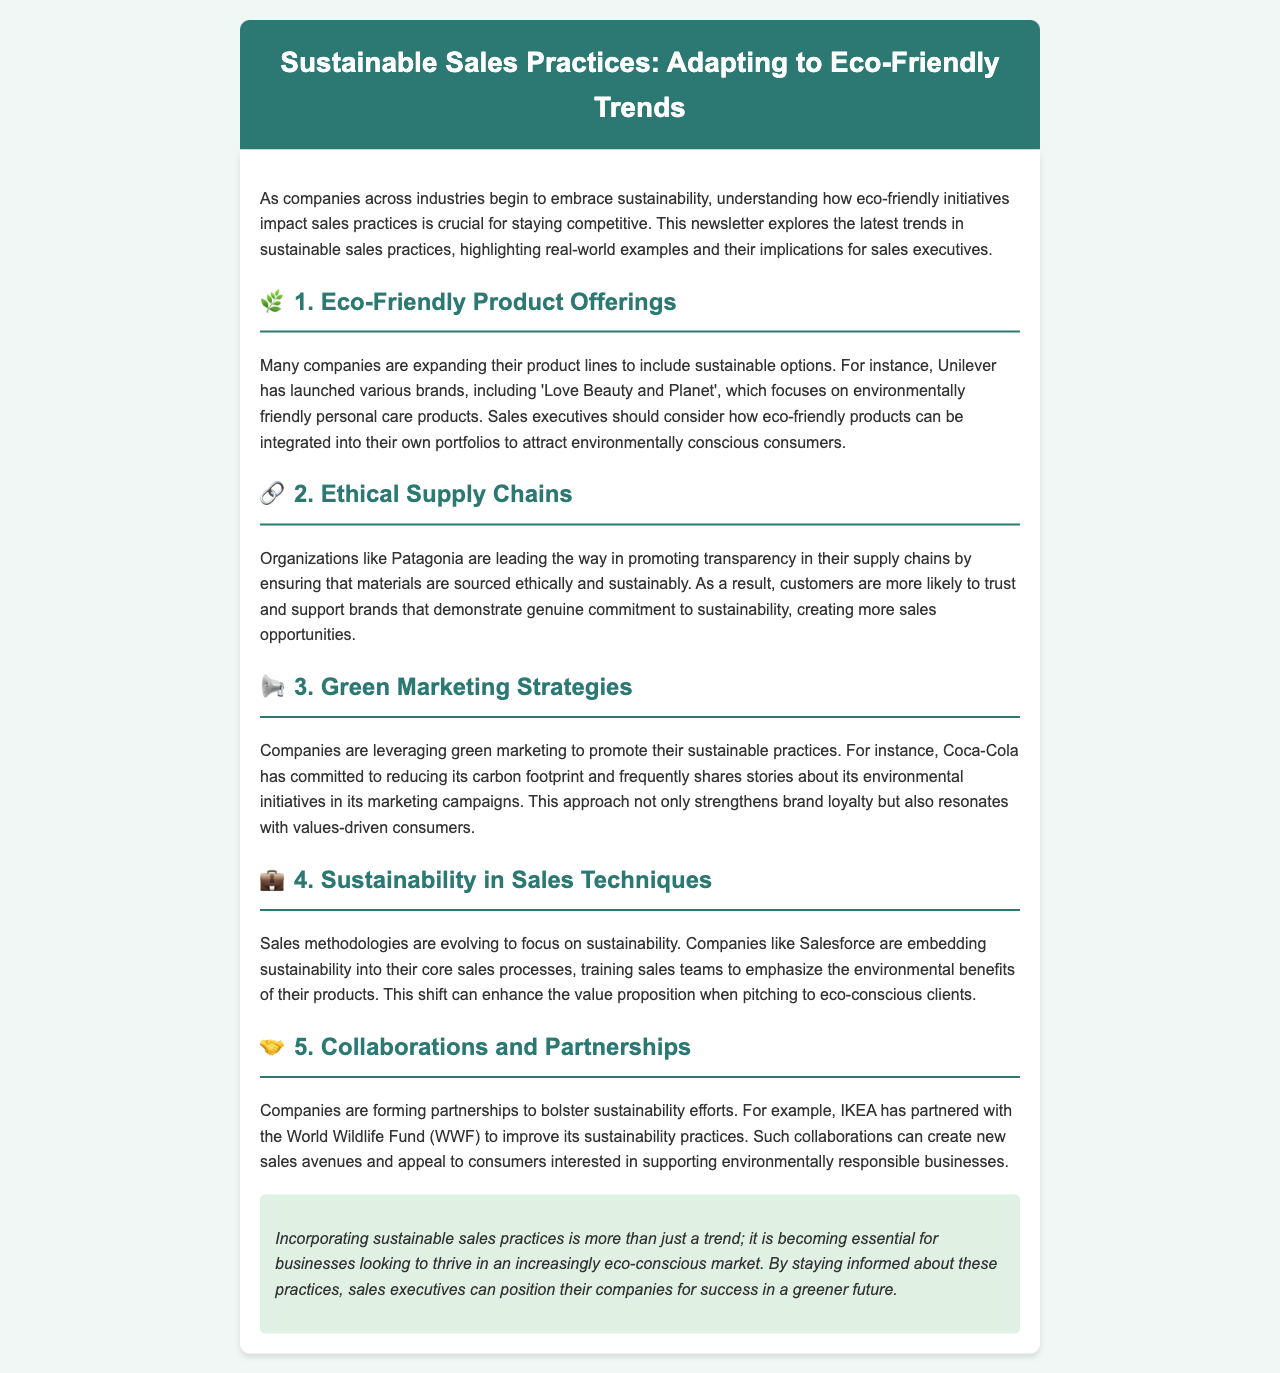What is the title of the newsletter? The title of the newsletter is provided at the top of the document in the header section.
Answer: Sustainable Sales Practices: Adapting to Eco-Friendly Trends Which company launched the 'Love Beauty and Planet' brand? This information can be found in the section discussing eco-friendly product offerings.
Answer: Unilever What does Patagonia promote in their supply chains? The document discusses the company’s focus on a specific aspect of their supply chain management.
Answer: Transparency What marketing strategy does Coca-Cola use to promote sustainability? The newsletter highlights their approach towards sustainability in marketing campaigns.
Answer: Green marketing Which organization did IKEA partner with to improve its sustainability practices? This partnership is mentioned in the collaborations and partnerships section.
Answer: World Wildlife Fund (WWF) How are sales methodologies evolving according to the newsletter? The document mentions an aspect of sales techniques that is becoming prominent.
Answer: Focus on sustainability What emoji represents ethical supply chains in the newsletter? There is a specific symbol used in the document for this section.
Answer: 🔗 What is becoming essential for businesses according to the conclusion? The final thoughts of the newsletter talk about a necessity for companies in a changing market.
Answer: Incorporating sustainable sales practices 